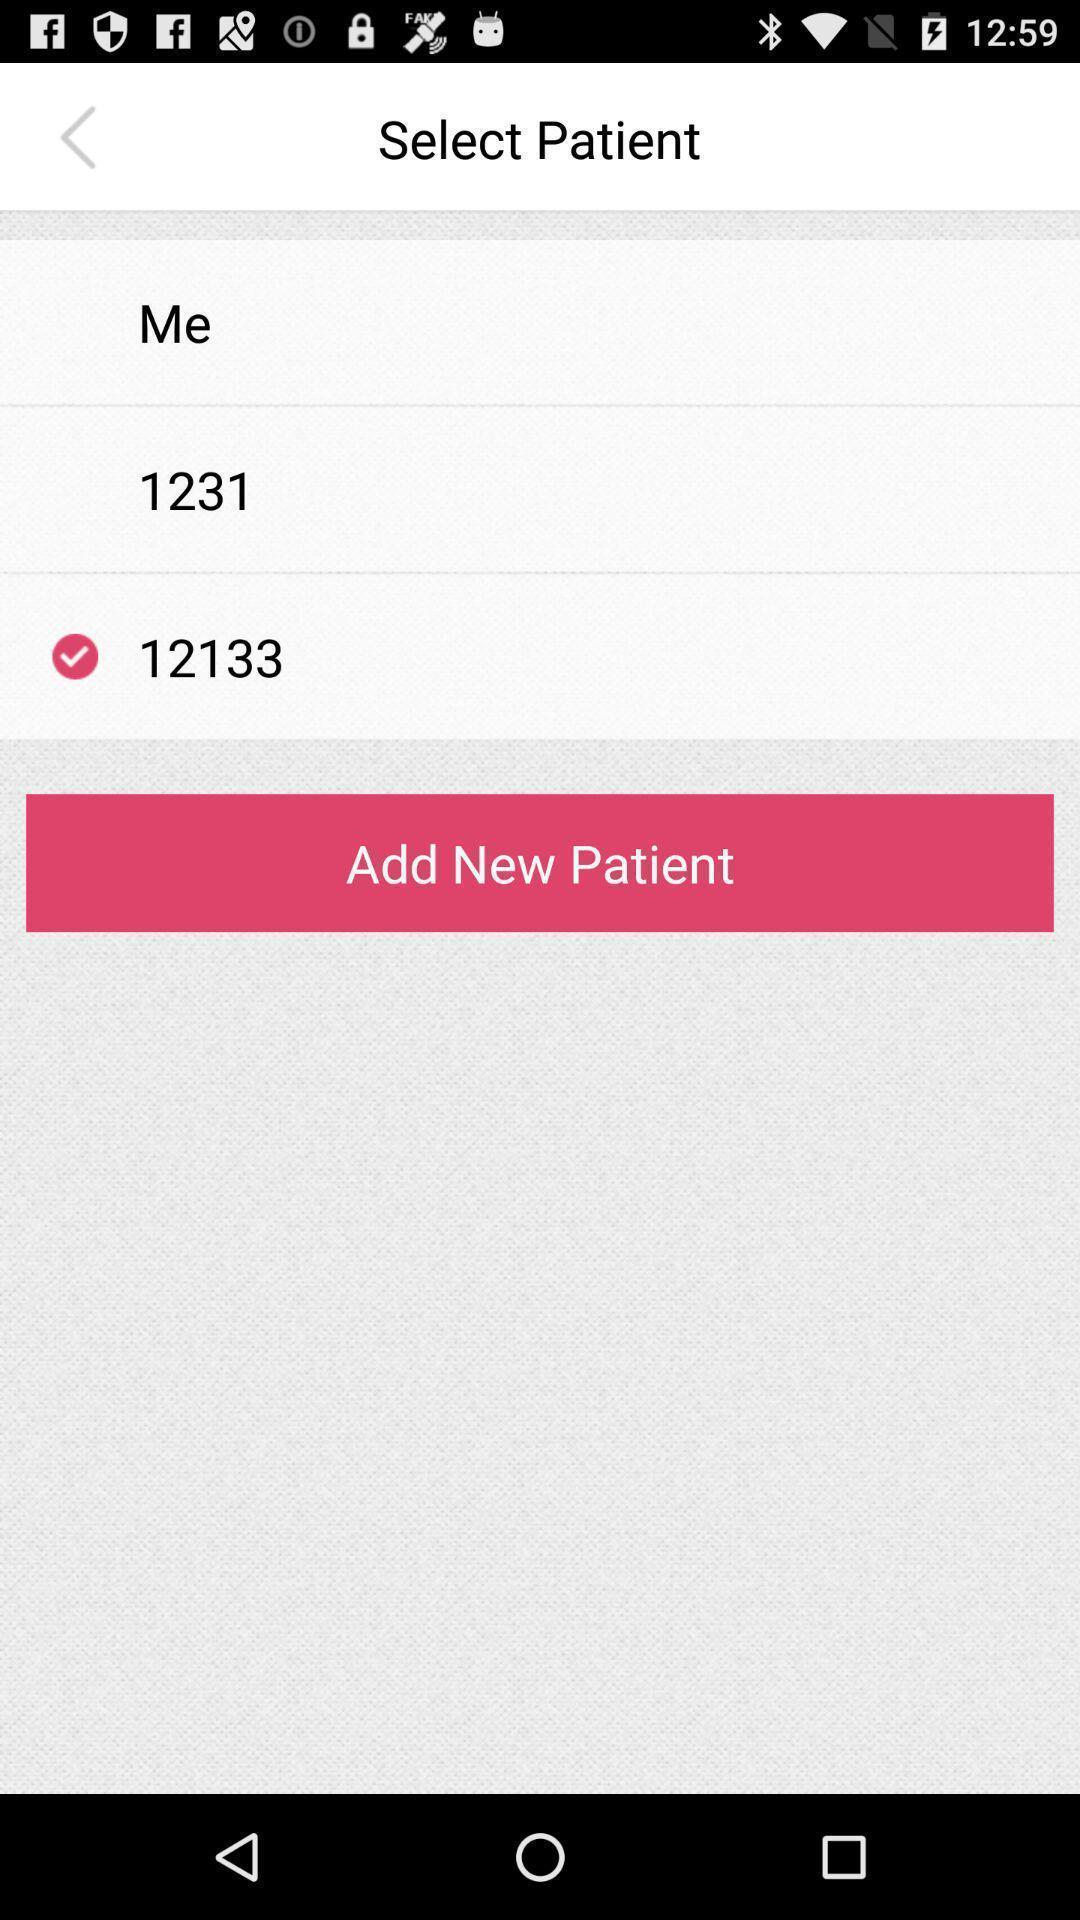Provide a description of this screenshot. Page for adding and selecting patient. 